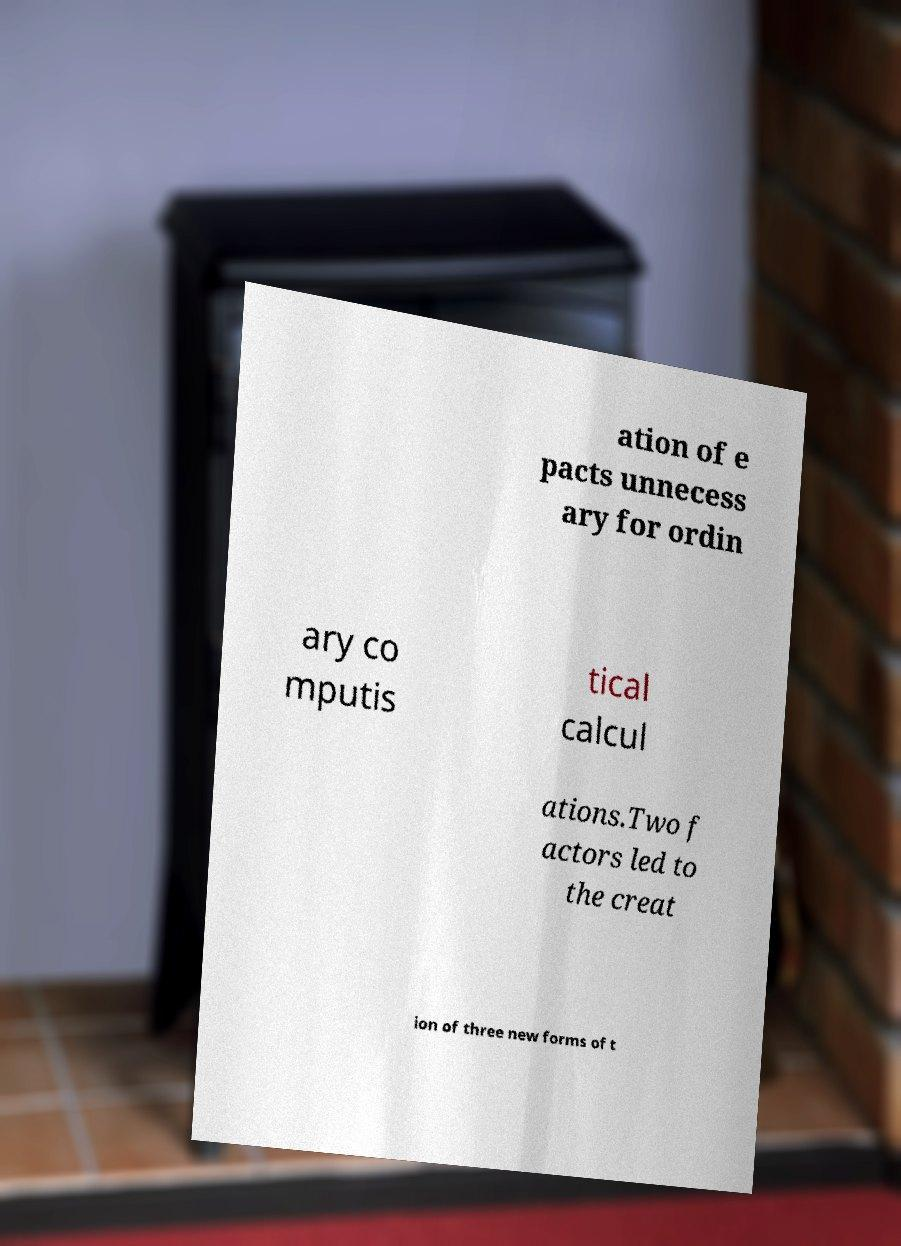Could you extract and type out the text from this image? ation of e pacts unnecess ary for ordin ary co mputis tical calcul ations.Two f actors led to the creat ion of three new forms of t 